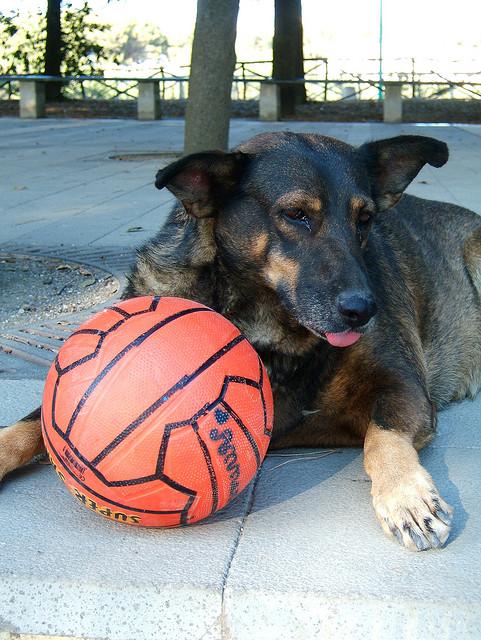What kind of ball does the dog have?
Keep it brief. Basketball. Is the dog's tongue sticking out?
Quick response, please. Yes. What breed of dog is this?
Answer briefly. German shepherd. 